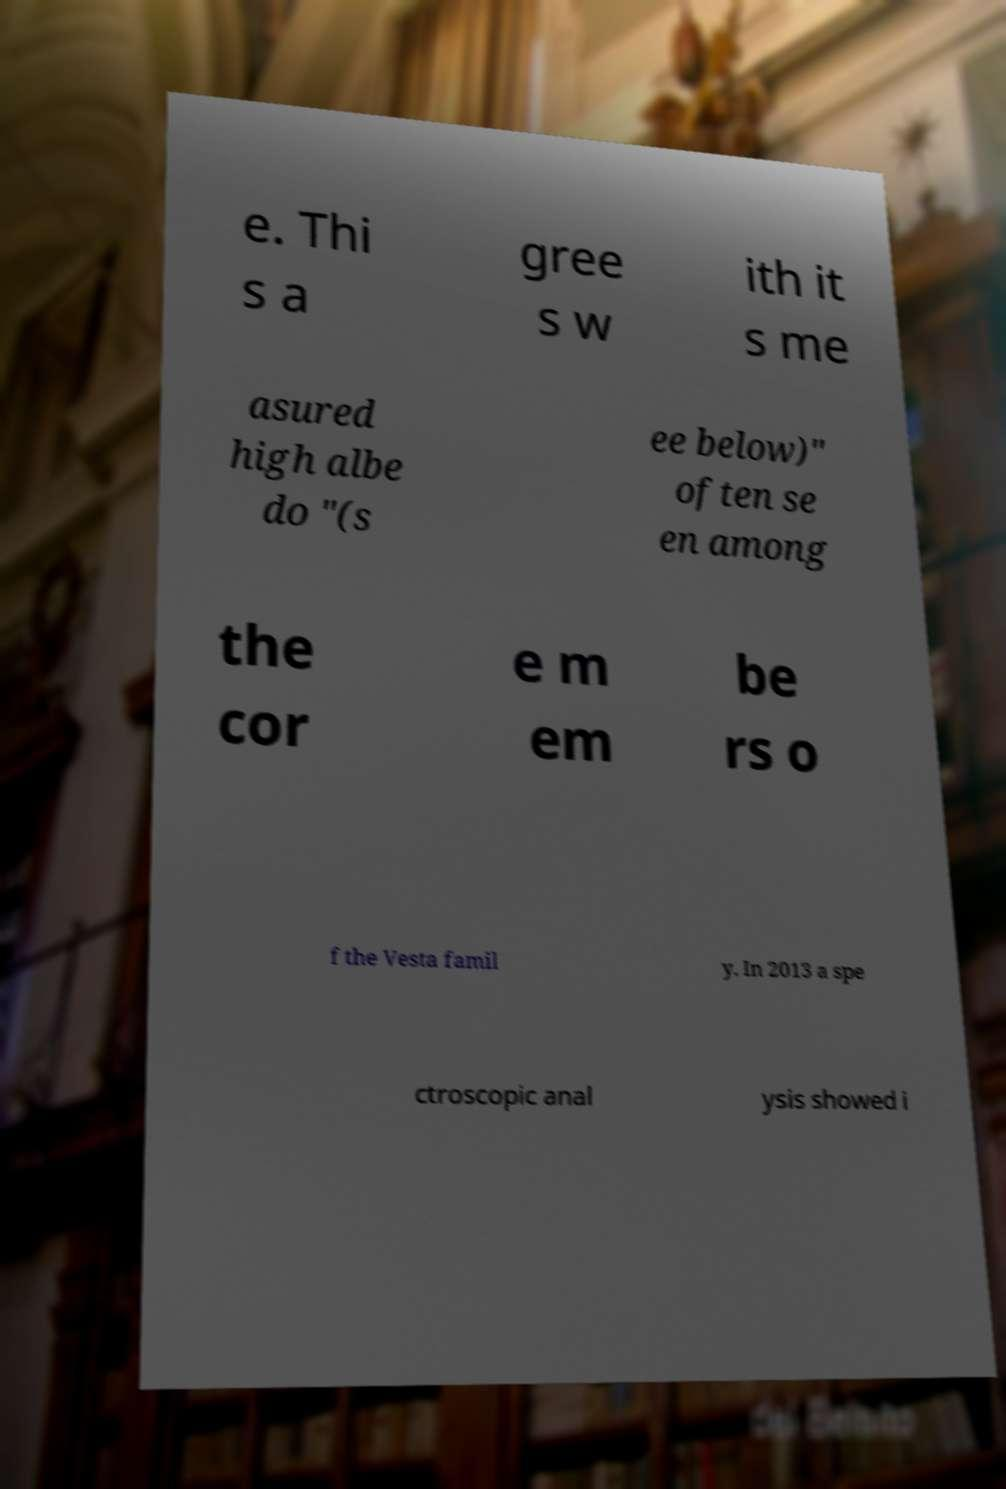Could you assist in decoding the text presented in this image and type it out clearly? e. Thi s a gree s w ith it s me asured high albe do "(s ee below)" often se en among the cor e m em be rs o f the Vesta famil y. In 2013 a spe ctroscopic anal ysis showed i 